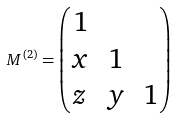<formula> <loc_0><loc_0><loc_500><loc_500>M ^ { ( 2 ) } = \begin{pmatrix} 1 & & \\ x & 1 & \\ z & y & 1 \end{pmatrix}</formula> 